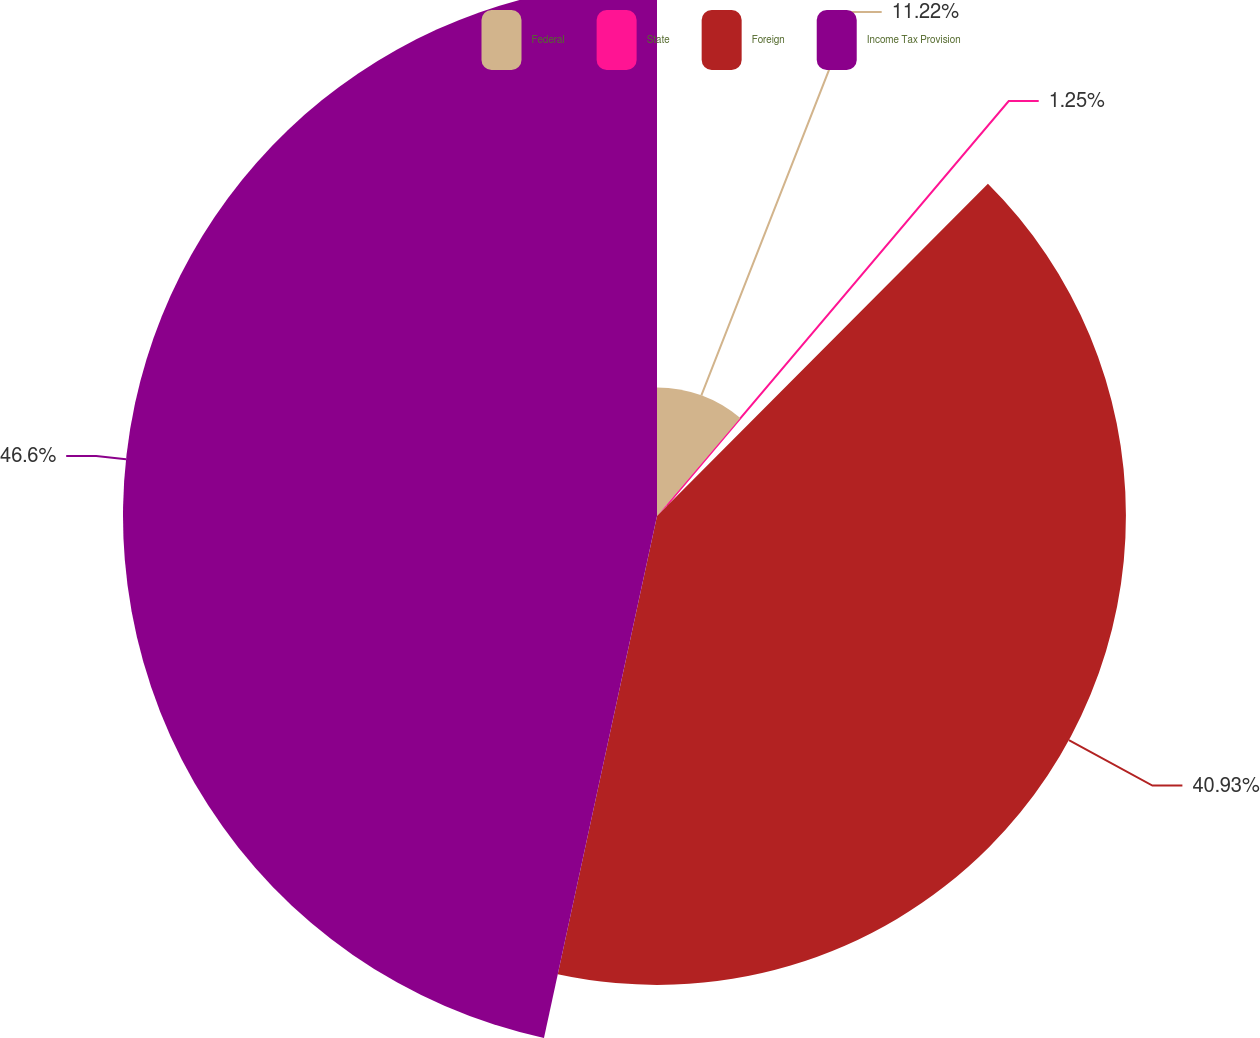Convert chart. <chart><loc_0><loc_0><loc_500><loc_500><pie_chart><fcel>Federal<fcel>State<fcel>Foreign<fcel>Income Tax Provision<nl><fcel>11.22%<fcel>1.25%<fcel>40.93%<fcel>46.61%<nl></chart> 